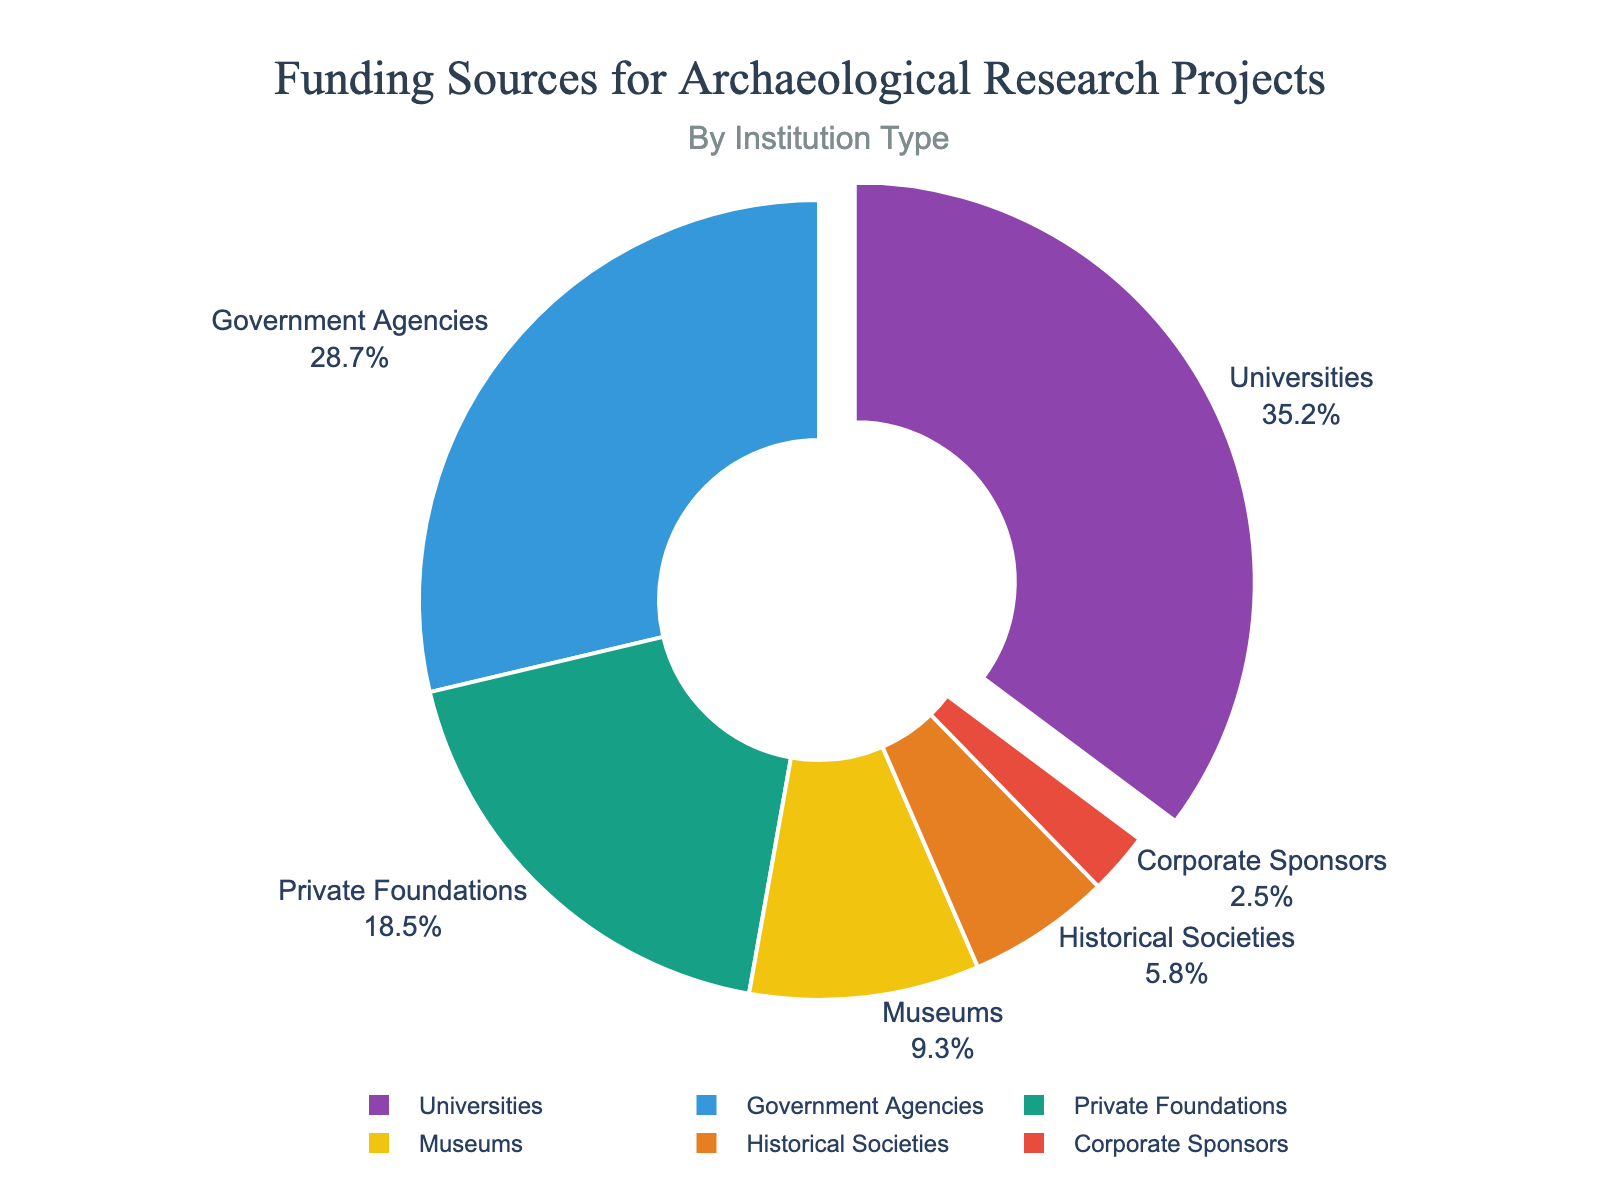What is the institution type that contributes the highest percentage of funding? The institution type that contributes the highest percentage of funding can be identified by looking at the segment that occupies the largest portion of the pie chart. From the data, we see that "Universities" have the highest funding percentage of 35.2%.
Answer: Universities Which institution type provides less funding, museums or historical societies? To determine which institution type provides less funding between museums and historical societies, we compare their respective percentages. Museums contribute 9.3%, whereas historical societies contribute 5.8%. Hence, historical societies provide less funding than museums.
Answer: Historical Societies What is the combined funding percentage of government agencies and private foundations? To find the combined funding percentage of government agencies and private foundations, we simply add their individual percentages: 28.7% (government agencies) + 18.5% (private foundations).
Answer: 47.2% How much bigger is the funding percentage from universities compared to corporate sponsors? To find the difference in funding percentage between universities and corporate sponsors, subtract the percentage of corporate sponsors (2.5%) from that of universities (35.2%). 35.2% - 2.5% = 32.7%.
Answer: 32.7% Are private foundations or museums closer in funding percentage to historical societies? To determine which is closer in funding percentage to historical societies, we calculate the absolute differences: Private foundations (18.5%) - Historical societies (5.8%) = 12.7%, Museums (9.3%) - Historical societies (5.8%) = 3.5%. Museums have a smaller absolute difference compared to historical societies.
Answer: Museums What is the percentage difference between the top two funding sources? The top two funding sources are universities (35.2%) and government agencies (28.7%). The percentage difference is calculated by subtracting the two: 35.2% - 28.7% = 6.5%.
Answer: 6.5% What is the average funding percentage of institutions other than universities? To find the average funding percentage of institutions other than universities, sum the percentages of the remaining institutions and divide by their number: (28.7 + 18.5 + 9.3 + 5.8 + 2.5) / 5 = 64.8 / 5 = 12.96%.
Answer: 12.96% Which color represents corporate sponsors in the pie chart? The color assignment starts from universities in the provided sequence: purple, blue, teal, yellow, orange, red. The sixth color (red) corresponds to corporate sponsors.
Answer: Red 